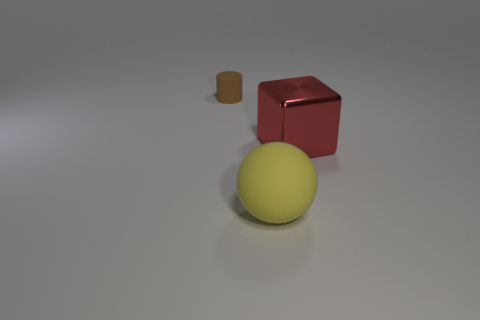Add 3 tiny brown things. How many objects exist? 6 Subtract all balls. How many objects are left? 2 Subtract all big red rubber things. Subtract all large matte spheres. How many objects are left? 2 Add 2 big red metallic things. How many big red metallic things are left? 3 Add 1 tiny purple rubber cylinders. How many tiny purple rubber cylinders exist? 1 Subtract 0 purple blocks. How many objects are left? 3 